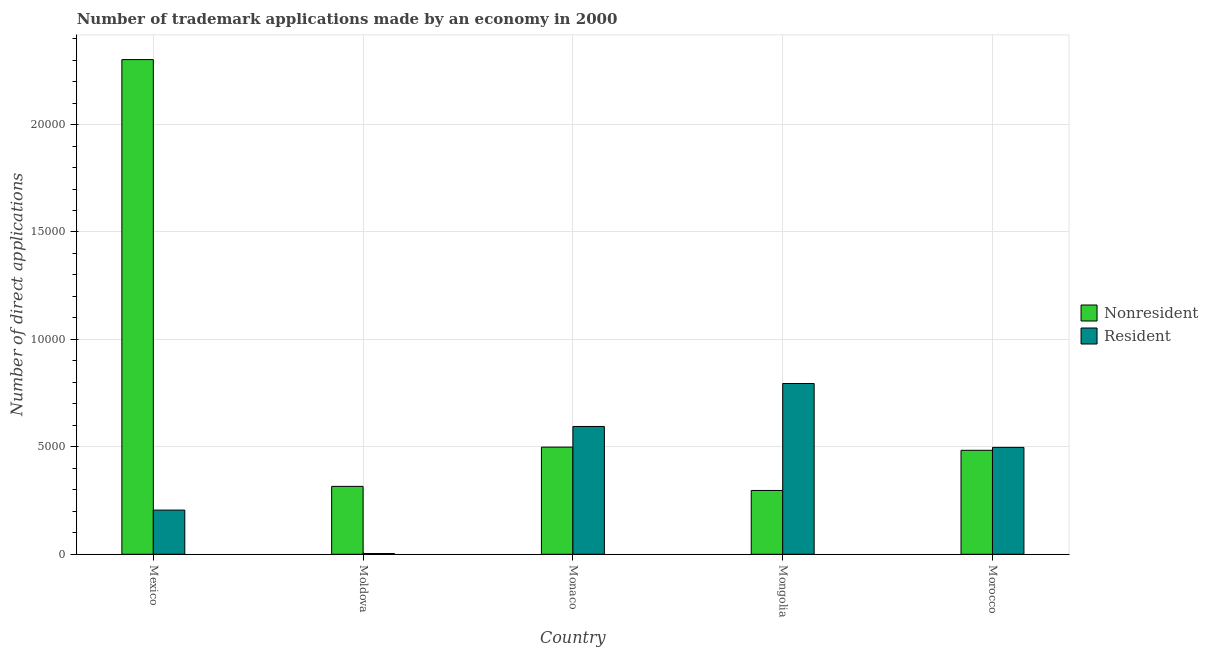How many different coloured bars are there?
Your response must be concise. 2. How many groups of bars are there?
Make the answer very short. 5. Are the number of bars on each tick of the X-axis equal?
Offer a very short reply. Yes. How many bars are there on the 1st tick from the left?
Provide a succinct answer. 2. How many bars are there on the 2nd tick from the right?
Your response must be concise. 2. What is the number of trademark applications made by non residents in Monaco?
Your response must be concise. 4987. Across all countries, what is the maximum number of trademark applications made by non residents?
Your response must be concise. 2.30e+04. Across all countries, what is the minimum number of trademark applications made by non residents?
Provide a succinct answer. 2970. In which country was the number of trademark applications made by non residents maximum?
Your response must be concise. Mexico. In which country was the number of trademark applications made by non residents minimum?
Offer a very short reply. Mongolia. What is the total number of trademark applications made by non residents in the graph?
Your response must be concise. 3.90e+04. What is the difference between the number of trademark applications made by residents in Mexico and that in Moldova?
Your answer should be very brief. 2022. What is the difference between the number of trademark applications made by residents in Mexico and the number of trademark applications made by non residents in Mongolia?
Provide a succinct answer. -913. What is the average number of trademark applications made by residents per country?
Ensure brevity in your answer.  4192.8. What is the difference between the number of trademark applications made by non residents and number of trademark applications made by residents in Moldova?
Keep it short and to the point. 3125. In how many countries, is the number of trademark applications made by residents greater than 10000 ?
Your response must be concise. 0. What is the ratio of the number of trademark applications made by residents in Monaco to that in Morocco?
Make the answer very short. 1.2. Is the difference between the number of trademark applications made by non residents in Monaco and Morocco greater than the difference between the number of trademark applications made by residents in Monaco and Morocco?
Provide a succinct answer. No. What is the difference between the highest and the second highest number of trademark applications made by non residents?
Your answer should be compact. 1.80e+04. What is the difference between the highest and the lowest number of trademark applications made by non residents?
Keep it short and to the point. 2.01e+04. In how many countries, is the number of trademark applications made by non residents greater than the average number of trademark applications made by non residents taken over all countries?
Offer a terse response. 1. What does the 1st bar from the left in Mongolia represents?
Provide a succinct answer. Nonresident. What does the 2nd bar from the right in Mexico represents?
Give a very brief answer. Nonresident. How many bars are there?
Your answer should be compact. 10. Are all the bars in the graph horizontal?
Offer a terse response. No. How many countries are there in the graph?
Ensure brevity in your answer.  5. How many legend labels are there?
Offer a terse response. 2. What is the title of the graph?
Your response must be concise. Number of trademark applications made by an economy in 2000. Does "From World Bank" appear as one of the legend labels in the graph?
Keep it short and to the point. No. What is the label or title of the Y-axis?
Give a very brief answer. Number of direct applications. What is the Number of direct applications in Nonresident in Mexico?
Offer a terse response. 2.30e+04. What is the Number of direct applications of Resident in Mexico?
Provide a short and direct response. 2057. What is the Number of direct applications of Nonresident in Moldova?
Provide a succinct answer. 3160. What is the Number of direct applications of Nonresident in Monaco?
Offer a very short reply. 4987. What is the Number of direct applications of Resident in Monaco?
Keep it short and to the point. 5949. What is the Number of direct applications in Nonresident in Mongolia?
Your response must be concise. 2970. What is the Number of direct applications of Resident in Mongolia?
Offer a very short reply. 7948. What is the Number of direct applications of Nonresident in Morocco?
Your response must be concise. 4839. What is the Number of direct applications in Resident in Morocco?
Your answer should be very brief. 4975. Across all countries, what is the maximum Number of direct applications in Nonresident?
Your answer should be very brief. 2.30e+04. Across all countries, what is the maximum Number of direct applications in Resident?
Offer a terse response. 7948. Across all countries, what is the minimum Number of direct applications of Nonresident?
Offer a very short reply. 2970. What is the total Number of direct applications in Nonresident in the graph?
Keep it short and to the point. 3.90e+04. What is the total Number of direct applications of Resident in the graph?
Your answer should be very brief. 2.10e+04. What is the difference between the Number of direct applications of Nonresident in Mexico and that in Moldova?
Your answer should be compact. 1.99e+04. What is the difference between the Number of direct applications of Resident in Mexico and that in Moldova?
Your answer should be very brief. 2022. What is the difference between the Number of direct applications of Nonresident in Mexico and that in Monaco?
Make the answer very short. 1.80e+04. What is the difference between the Number of direct applications in Resident in Mexico and that in Monaco?
Offer a very short reply. -3892. What is the difference between the Number of direct applications of Nonresident in Mexico and that in Mongolia?
Offer a terse response. 2.01e+04. What is the difference between the Number of direct applications in Resident in Mexico and that in Mongolia?
Make the answer very short. -5891. What is the difference between the Number of direct applications of Nonresident in Mexico and that in Morocco?
Provide a short and direct response. 1.82e+04. What is the difference between the Number of direct applications of Resident in Mexico and that in Morocco?
Offer a terse response. -2918. What is the difference between the Number of direct applications of Nonresident in Moldova and that in Monaco?
Give a very brief answer. -1827. What is the difference between the Number of direct applications in Resident in Moldova and that in Monaco?
Your response must be concise. -5914. What is the difference between the Number of direct applications of Nonresident in Moldova and that in Mongolia?
Your answer should be compact. 190. What is the difference between the Number of direct applications of Resident in Moldova and that in Mongolia?
Your answer should be very brief. -7913. What is the difference between the Number of direct applications of Nonresident in Moldova and that in Morocco?
Offer a terse response. -1679. What is the difference between the Number of direct applications of Resident in Moldova and that in Morocco?
Your response must be concise. -4940. What is the difference between the Number of direct applications of Nonresident in Monaco and that in Mongolia?
Give a very brief answer. 2017. What is the difference between the Number of direct applications in Resident in Monaco and that in Mongolia?
Offer a terse response. -1999. What is the difference between the Number of direct applications of Nonresident in Monaco and that in Morocco?
Keep it short and to the point. 148. What is the difference between the Number of direct applications in Resident in Monaco and that in Morocco?
Offer a very short reply. 974. What is the difference between the Number of direct applications in Nonresident in Mongolia and that in Morocco?
Give a very brief answer. -1869. What is the difference between the Number of direct applications of Resident in Mongolia and that in Morocco?
Provide a succinct answer. 2973. What is the difference between the Number of direct applications of Nonresident in Mexico and the Number of direct applications of Resident in Moldova?
Make the answer very short. 2.30e+04. What is the difference between the Number of direct applications in Nonresident in Mexico and the Number of direct applications in Resident in Monaco?
Keep it short and to the point. 1.71e+04. What is the difference between the Number of direct applications in Nonresident in Mexico and the Number of direct applications in Resident in Mongolia?
Offer a terse response. 1.51e+04. What is the difference between the Number of direct applications of Nonresident in Mexico and the Number of direct applications of Resident in Morocco?
Ensure brevity in your answer.  1.80e+04. What is the difference between the Number of direct applications in Nonresident in Moldova and the Number of direct applications in Resident in Monaco?
Provide a short and direct response. -2789. What is the difference between the Number of direct applications of Nonresident in Moldova and the Number of direct applications of Resident in Mongolia?
Make the answer very short. -4788. What is the difference between the Number of direct applications in Nonresident in Moldova and the Number of direct applications in Resident in Morocco?
Make the answer very short. -1815. What is the difference between the Number of direct applications in Nonresident in Monaco and the Number of direct applications in Resident in Mongolia?
Your response must be concise. -2961. What is the difference between the Number of direct applications of Nonresident in Monaco and the Number of direct applications of Resident in Morocco?
Offer a very short reply. 12. What is the difference between the Number of direct applications in Nonresident in Mongolia and the Number of direct applications in Resident in Morocco?
Your answer should be compact. -2005. What is the average Number of direct applications of Nonresident per country?
Provide a succinct answer. 7795.8. What is the average Number of direct applications in Resident per country?
Provide a short and direct response. 4192.8. What is the difference between the Number of direct applications of Nonresident and Number of direct applications of Resident in Mexico?
Your answer should be compact. 2.10e+04. What is the difference between the Number of direct applications of Nonresident and Number of direct applications of Resident in Moldova?
Make the answer very short. 3125. What is the difference between the Number of direct applications of Nonresident and Number of direct applications of Resident in Monaco?
Your answer should be compact. -962. What is the difference between the Number of direct applications in Nonresident and Number of direct applications in Resident in Mongolia?
Your answer should be compact. -4978. What is the difference between the Number of direct applications of Nonresident and Number of direct applications of Resident in Morocco?
Your response must be concise. -136. What is the ratio of the Number of direct applications in Nonresident in Mexico to that in Moldova?
Your response must be concise. 7.29. What is the ratio of the Number of direct applications of Resident in Mexico to that in Moldova?
Give a very brief answer. 58.77. What is the ratio of the Number of direct applications of Nonresident in Mexico to that in Monaco?
Give a very brief answer. 4.62. What is the ratio of the Number of direct applications in Resident in Mexico to that in Monaco?
Keep it short and to the point. 0.35. What is the ratio of the Number of direct applications in Nonresident in Mexico to that in Mongolia?
Offer a very short reply. 7.75. What is the ratio of the Number of direct applications in Resident in Mexico to that in Mongolia?
Make the answer very short. 0.26. What is the ratio of the Number of direct applications of Nonresident in Mexico to that in Morocco?
Offer a very short reply. 4.76. What is the ratio of the Number of direct applications of Resident in Mexico to that in Morocco?
Provide a succinct answer. 0.41. What is the ratio of the Number of direct applications in Nonresident in Moldova to that in Monaco?
Offer a very short reply. 0.63. What is the ratio of the Number of direct applications of Resident in Moldova to that in Monaco?
Provide a succinct answer. 0.01. What is the ratio of the Number of direct applications in Nonresident in Moldova to that in Mongolia?
Your response must be concise. 1.06. What is the ratio of the Number of direct applications in Resident in Moldova to that in Mongolia?
Your answer should be compact. 0. What is the ratio of the Number of direct applications in Nonresident in Moldova to that in Morocco?
Offer a very short reply. 0.65. What is the ratio of the Number of direct applications in Resident in Moldova to that in Morocco?
Your response must be concise. 0.01. What is the ratio of the Number of direct applications of Nonresident in Monaco to that in Mongolia?
Keep it short and to the point. 1.68. What is the ratio of the Number of direct applications of Resident in Monaco to that in Mongolia?
Provide a succinct answer. 0.75. What is the ratio of the Number of direct applications in Nonresident in Monaco to that in Morocco?
Ensure brevity in your answer.  1.03. What is the ratio of the Number of direct applications of Resident in Monaco to that in Morocco?
Your answer should be compact. 1.2. What is the ratio of the Number of direct applications in Nonresident in Mongolia to that in Morocco?
Give a very brief answer. 0.61. What is the ratio of the Number of direct applications in Resident in Mongolia to that in Morocco?
Make the answer very short. 1.6. What is the difference between the highest and the second highest Number of direct applications of Nonresident?
Offer a very short reply. 1.80e+04. What is the difference between the highest and the second highest Number of direct applications of Resident?
Offer a very short reply. 1999. What is the difference between the highest and the lowest Number of direct applications in Nonresident?
Provide a short and direct response. 2.01e+04. What is the difference between the highest and the lowest Number of direct applications in Resident?
Provide a short and direct response. 7913. 